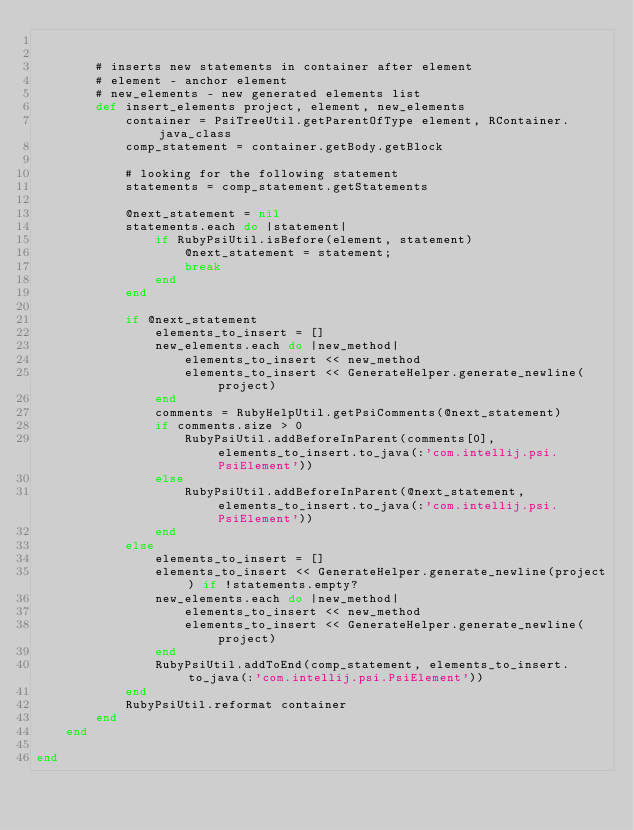<code> <loc_0><loc_0><loc_500><loc_500><_Ruby_>

        # inserts new statements in container after element
        # element - anchor element
        # new_elements - new generated elements list
        def insert_elements project, element, new_elements
            container = PsiTreeUtil.getParentOfType element, RContainer.java_class
            comp_statement = container.getBody.getBlock

            # looking for the following statement
            statements = comp_statement.getStatements

            @next_statement = nil
            statements.each do |statement|
                if RubyPsiUtil.isBefore(element, statement)
                    @next_statement = statement;
                    break
                end
            end

            if @next_statement
                elements_to_insert = []
                new_elements.each do |new_method|
                    elements_to_insert << new_method
                    elements_to_insert << GenerateHelper.generate_newline(project)
                end
                comments = RubyHelpUtil.getPsiComments(@next_statement)
                if comments.size > 0
                    RubyPsiUtil.addBeforeInParent(comments[0], elements_to_insert.to_java(:'com.intellij.psi.PsiElement'))
                else
                    RubyPsiUtil.addBeforeInParent(@next_statement, elements_to_insert.to_java(:'com.intellij.psi.PsiElement'))
                end
            else
                elements_to_insert = []
                elements_to_insert << GenerateHelper.generate_newline(project) if !statements.empty?
                new_elements.each do |new_method|
                    elements_to_insert << new_method
                    elements_to_insert << GenerateHelper.generate_newline(project)
                end
                RubyPsiUtil.addToEnd(comp_statement, elements_to_insert.to_java(:'com.intellij.psi.PsiElement'))
            end
            RubyPsiUtil.reformat container
        end
    end

end</code> 